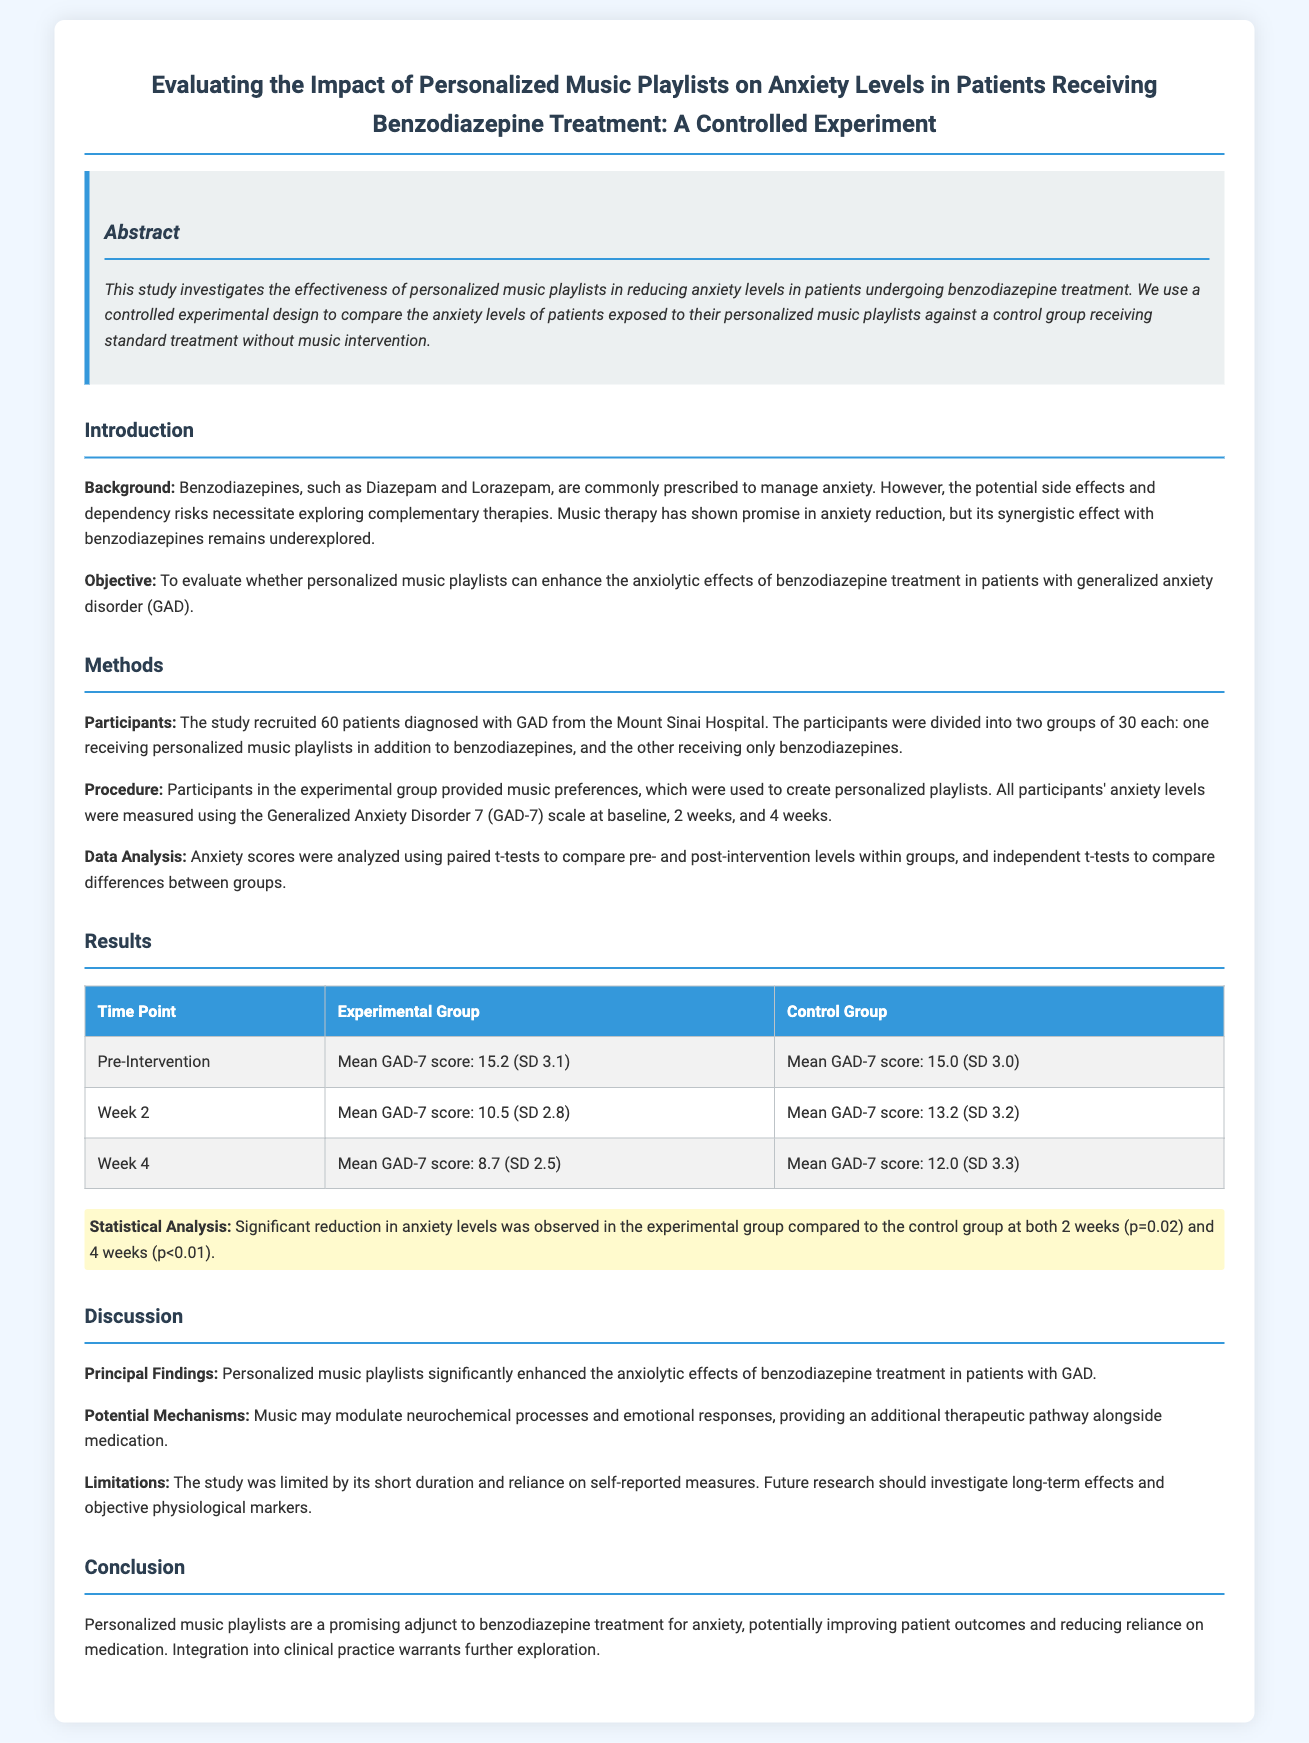What was the background of the study? The background states that benzodiazepines are commonly prescribed to manage anxiety and that the potential side effects necessitate exploring complementary therapies.
Answer: Benzodiazepines are commonly prescribed to manage anxiety What scale was used to measure anxiety levels? The document mentions that the Generalized Anxiety Disorder 7 (GAD-7) scale was used to measure anxiety levels in participants.
Answer: GAD-7 scale How many participants were in the experimental group? The experiment included 60 patients divided into two groups of 30 each, resulting in an experimental group of 30 participants.
Answer: 30 What was the mean GAD-7 score of the experimental group at Week 2? The table shows that the mean GAD-7 score for the experimental group at Week 2 was 10.5.
Answer: 10.5 What was the statistical significance of the results at Week 4? The highlighted text indicates that the results were statistically significant with a p-value of less than 0.01 at Week 4.
Answer: p<0.01 What is one potential mechanism through which music may help reduce anxiety? The discussion section notes that music may modulate neurochemical processes and emotional responses.
Answer: Modulate neurochemical processes What limitation was mentioned in the study? The document points out that a limitation of the study was its short duration and reliance on self-reported measures.
Answer: Short duration What is the conclusion regarding personalized music playlists? The conclusion states that personalized music playlists are a promising adjunct to benzodiazepine treatment for anxiety.
Answer: Promising adjunct to benzodiazepine treatment 